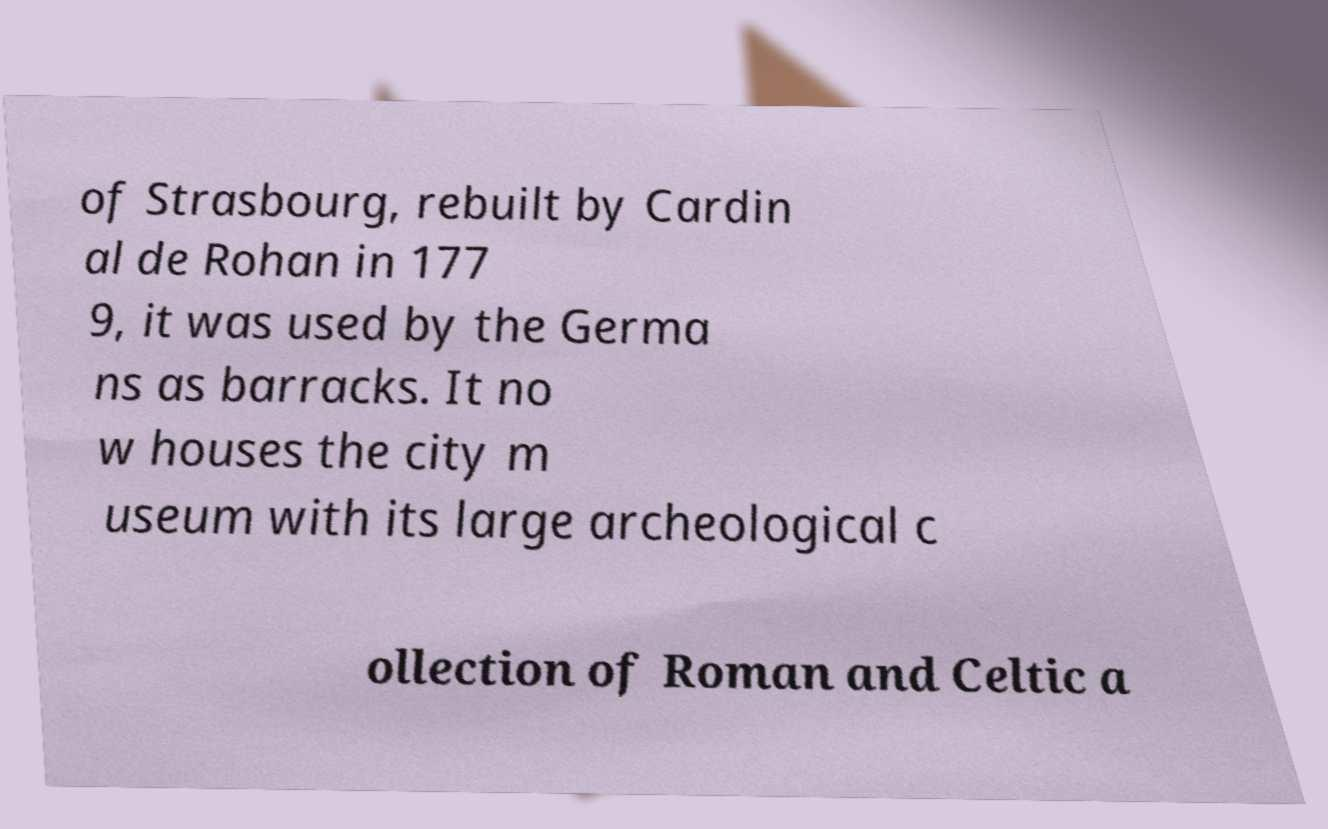I need the written content from this picture converted into text. Can you do that? of Strasbourg, rebuilt by Cardin al de Rohan in 177 9, it was used by the Germa ns as barracks. It no w houses the city m useum with its large archeological c ollection of Roman and Celtic a 